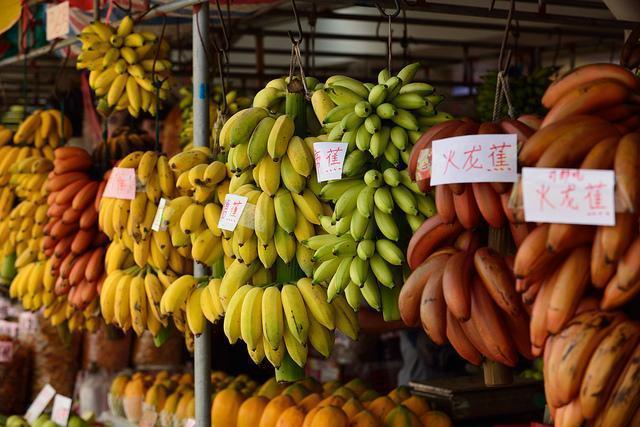How many bananas are there?
Give a very brief answer. 6. How many books are shown?
Give a very brief answer. 0. 